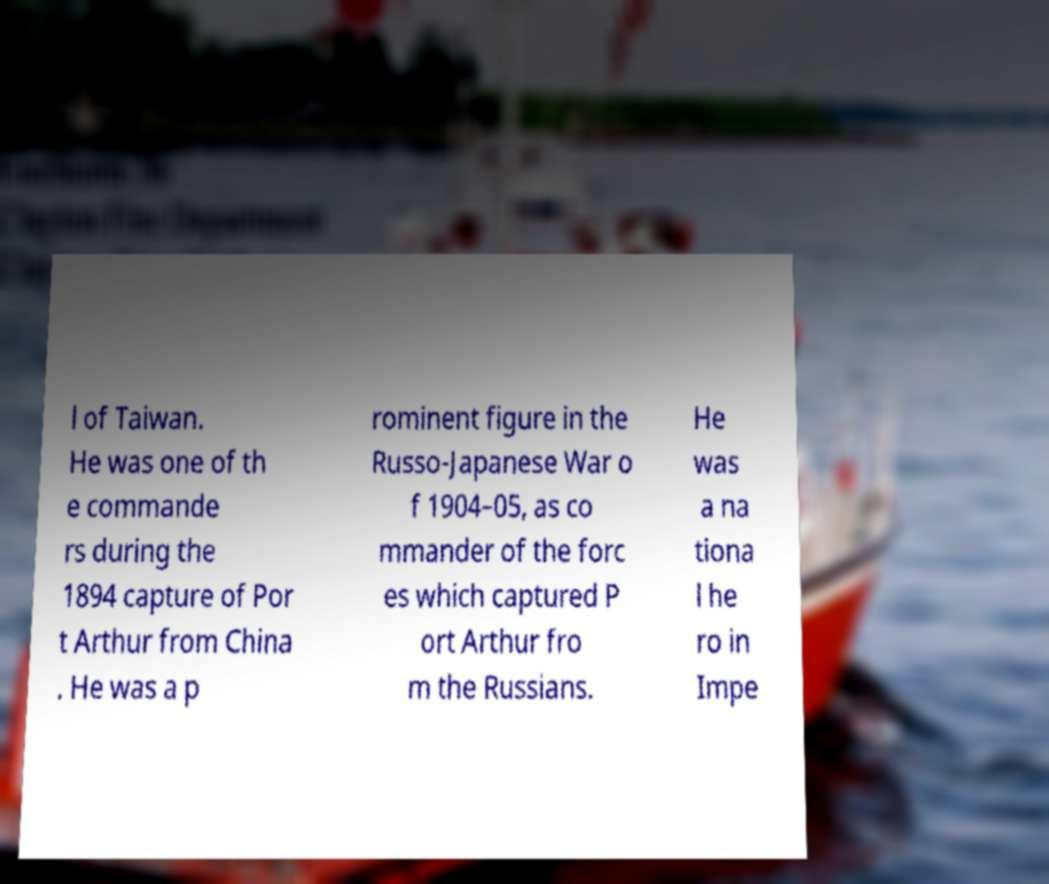Can you accurately transcribe the text from the provided image for me? l of Taiwan. He was one of th e commande rs during the 1894 capture of Por t Arthur from China . He was a p rominent figure in the Russo-Japanese War o f 1904–05, as co mmander of the forc es which captured P ort Arthur fro m the Russians. He was a na tiona l he ro in Impe 